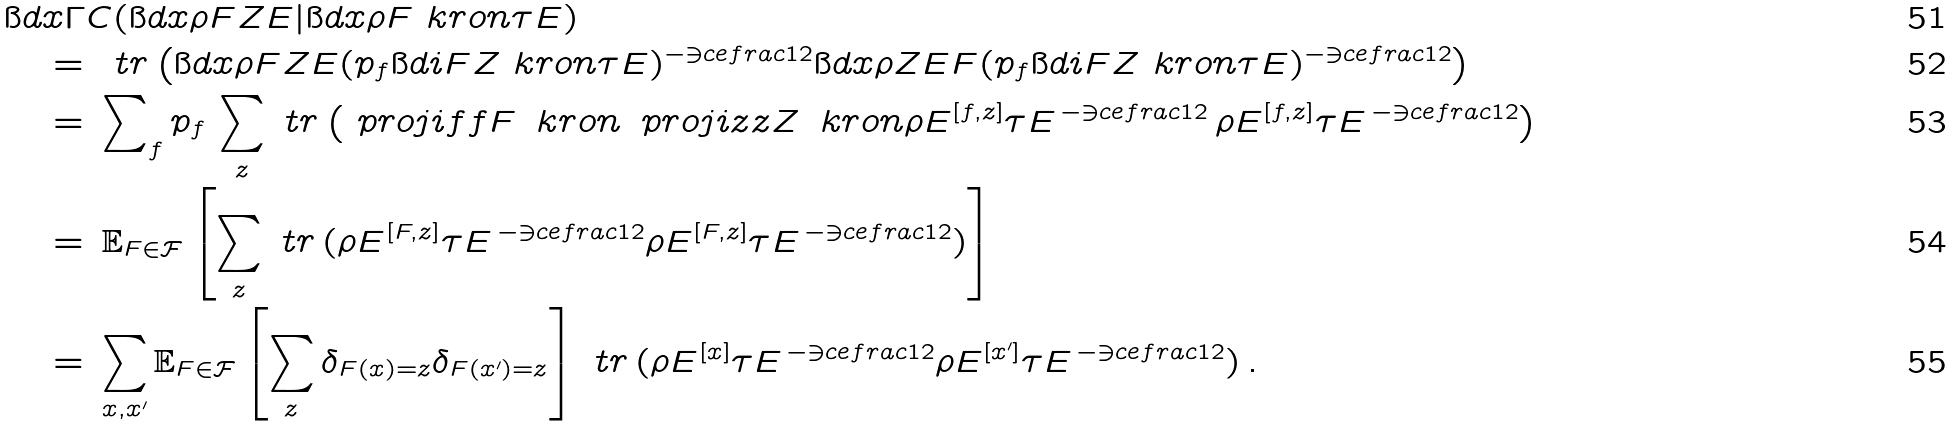<formula> <loc_0><loc_0><loc_500><loc_500>& \i d x { \Gamma } { C } ( \i d x { \rho } { F Z E } | \i d x { \rho } { F } \ k r o n \tau E ) \\ & \quad = \, \ t r \left ( \i d x { \rho } { F Z E } ( p _ { f } \i d i { F Z } \ k r o n \tau E ) ^ { - \ni c e f r a c { 1 } { 2 } } \i d x { \rho } { Z E F } ( p _ { f } \i d i { F Z } \ k r o n \tau E ) ^ { - \ni c e f r a c { 1 } { 2 } } \right ) \\ & \quad = \, { \sum } _ { f } \, p _ { f } \, \sum _ { z } \ t r \left ( \ p r o j i { f } { f } { F } \, \ k r o n \, \ p r o j i { z } { z } { Z } \, \ k r o n \rho E ^ { [ f , z ] } \tau E ^ { \, - \ni c e f r a c { 1 } { 2 } } \, \rho E ^ { [ f , z ] } \tau E ^ { \, - \ni c e f r a c { 1 } { 2 } } \right ) \\ & \quad = \, \mathbb { E } _ { F \in \mathcal { F } } \left [ \sum _ { z } \ t r \, ( \rho E ^ { [ F , z ] } \tau E ^ { \, - \ni c e f r a c { 1 } { 2 } } \rho E ^ { [ F , z ] } \tau E ^ { \, - \ni c e f r a c { 1 } { 2 } } ) \right ] \\ & \quad = \, \sum _ { x , x ^ { \prime } } \mathbb { E } _ { F \in \mathcal { F } } \left [ \sum _ { z } \delta _ { F ( x ) = z } \delta _ { F ( x ^ { \prime } ) = z } \right ] \ t r \, ( \rho E ^ { [ x ] } \tau E ^ { \, - \ni c e f r a c { 1 } { 2 } } \rho E ^ { [ x ^ { \prime } ] } \tau E ^ { \, - \ni c e f r a c { 1 } { 2 } } ) \, .</formula> 